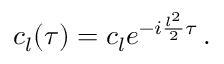Convert formula to latex. <formula><loc_0><loc_0><loc_500><loc_500>\begin{array} { r } { c _ { l } ( \tau ) = c _ { l } e ^ { - i \frac { l ^ { 2 } } { 2 } \tau } \, . } \end{array}</formula> 